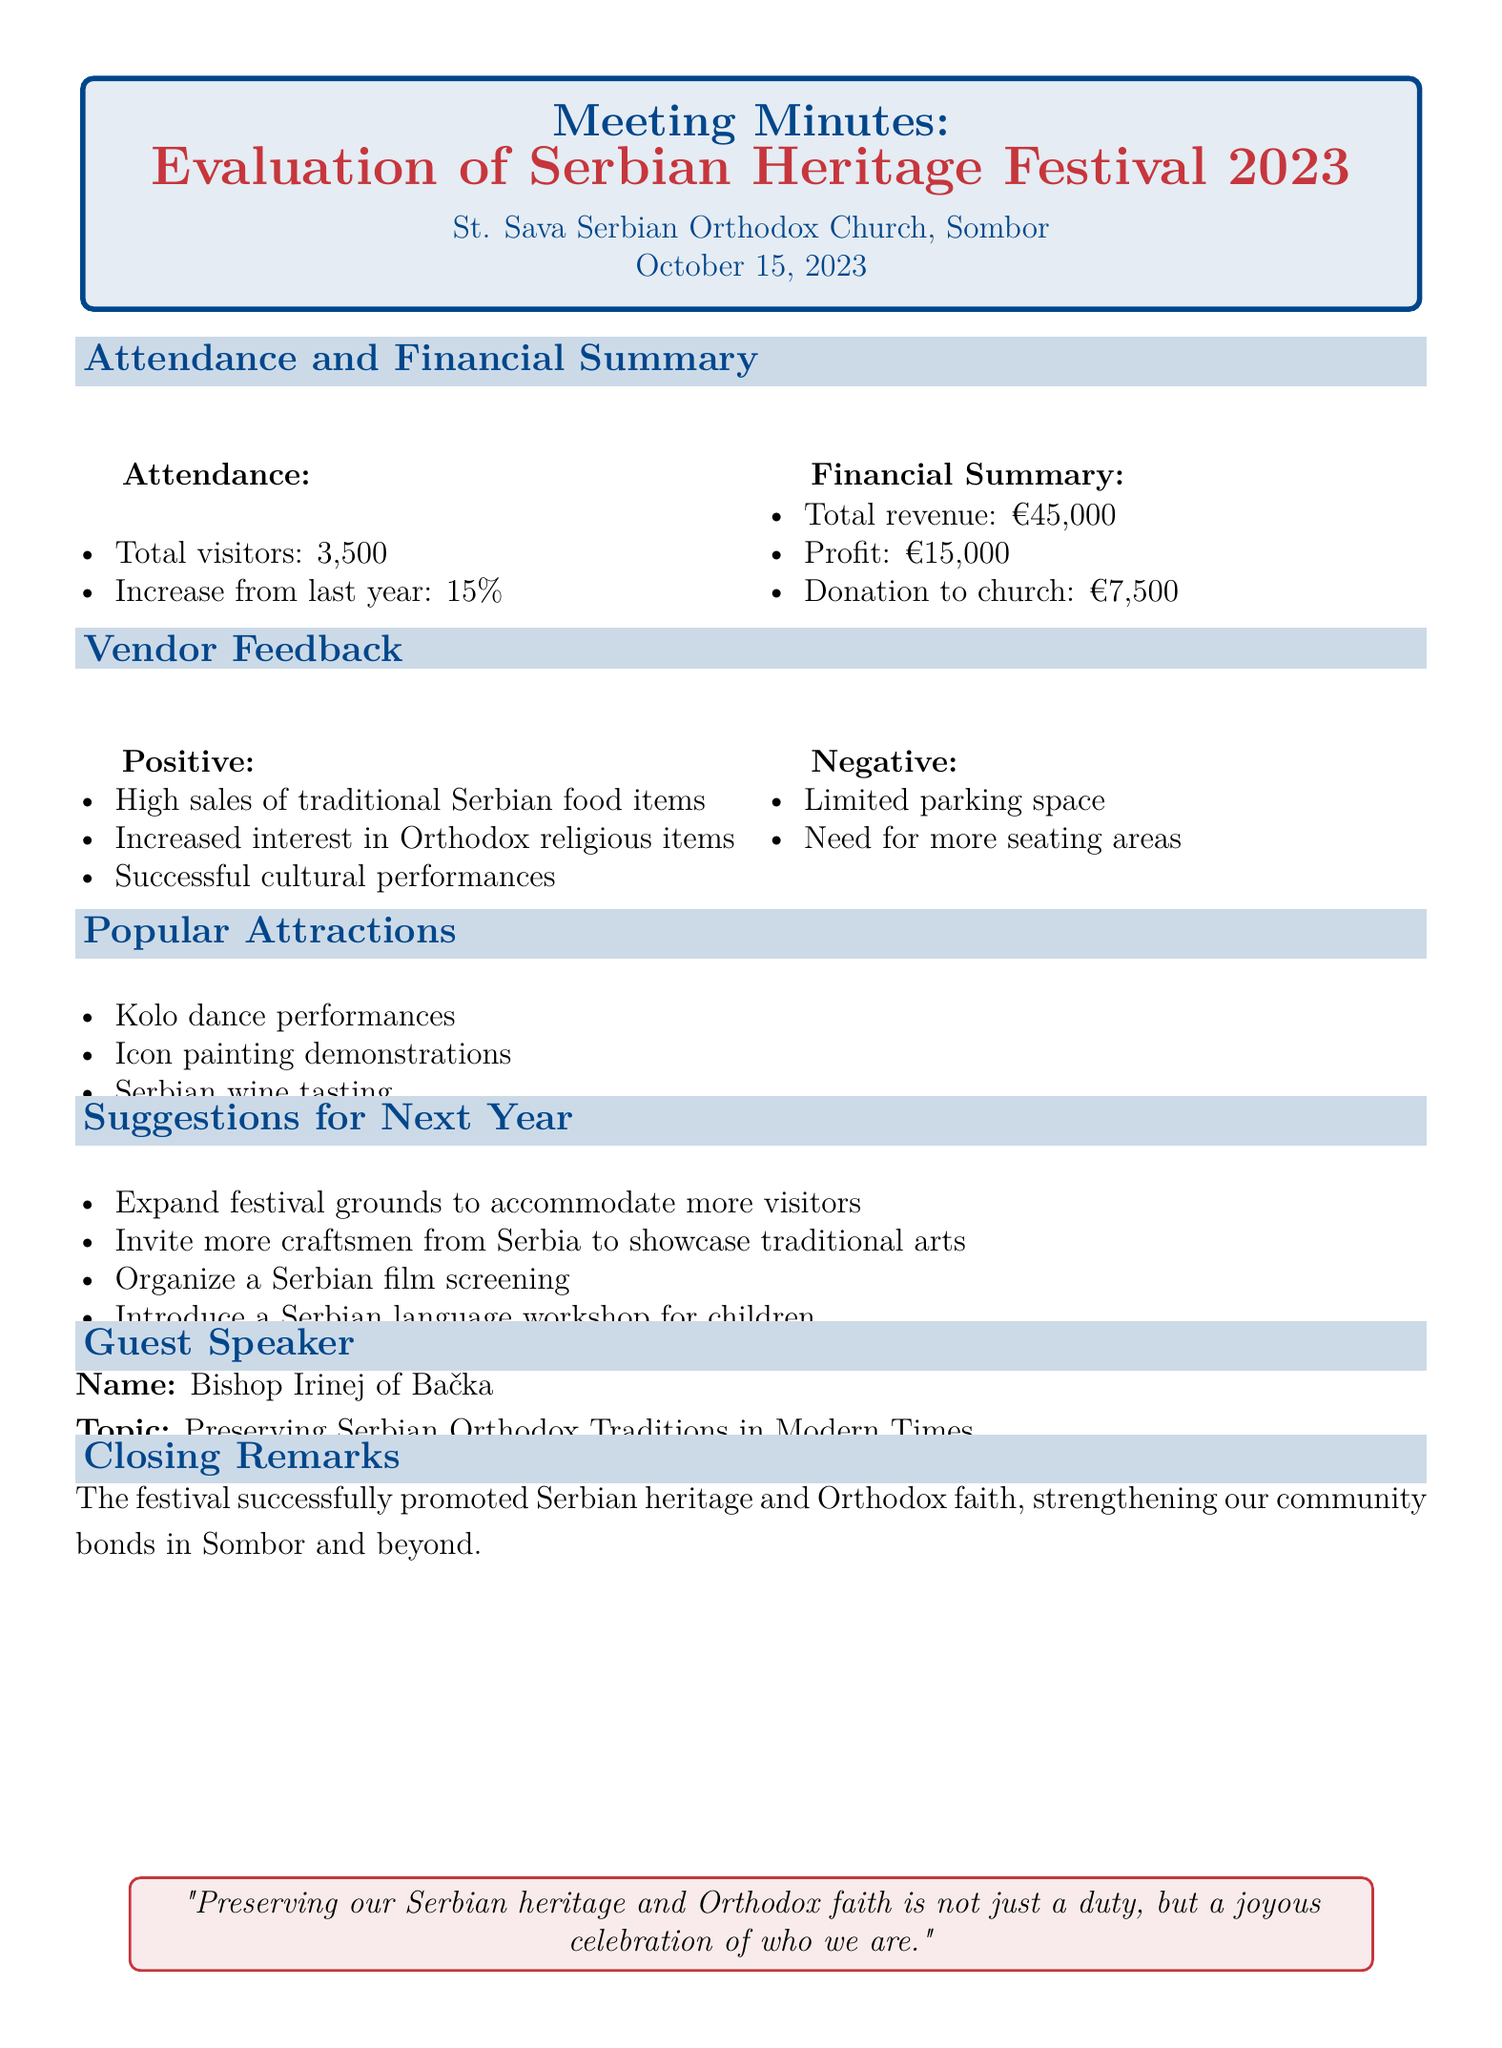What was the total attendance for the festival? The total attendance is stated in the document as the number of visitors who participated in the festival.
Answer: 3,500 What was the percentage increase in attendance from last year? The document specifies the change in attendance by providing the increase as a percentage compared to the previous year.
Answer: 15% Who was the guest speaker at the event? The document lists the name of the guest speaker, which is important information related to the meeting.
Answer: Bishop Irinej of Bačka What were two positive feedback points from vendors? The feedback from vendors includes a list of positive remarks noted in the document, which reflects their satisfaction.
Answer: High sales of traditional Serbian food items, Increased interest in Orthodox religious items How much profit did the festival generate? The profit figure is provided in the financial summary section of the document.
Answer: €15,000 What suggestion was made regarding festival grounds for next year? A suggestion is mentioned that relates to the physical space available for the festival in the future.
Answer: Expand festival grounds to accommodate more visitors What was one popular attraction listed in the festival? The document highlights several attractions that were enjoyed during the festival, reflecting the cultural activities offered.
Answer: Kolo dance performances What was the donation amount to the church from the festival revenue? The document provides a specific figure detailing how much money was donated to the church as a result of the festival.
Answer: €7,500 What was the closing remark of the meeting? The final remarks often summarize the overarching sentiments expressed during the meeting, which is noted in the document.
Answer: The festival successfully promoted Serbian heritage and Orthodox faith, strengthening our community bonds in Sombor and beyond 